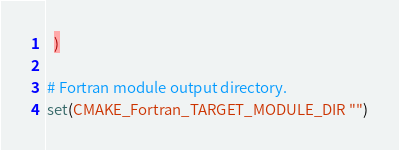Convert code to text. <code><loc_0><loc_0><loc_500><loc_500><_CMake_>  )

# Fortran module output directory.
set(CMAKE_Fortran_TARGET_MODULE_DIR "")
</code> 